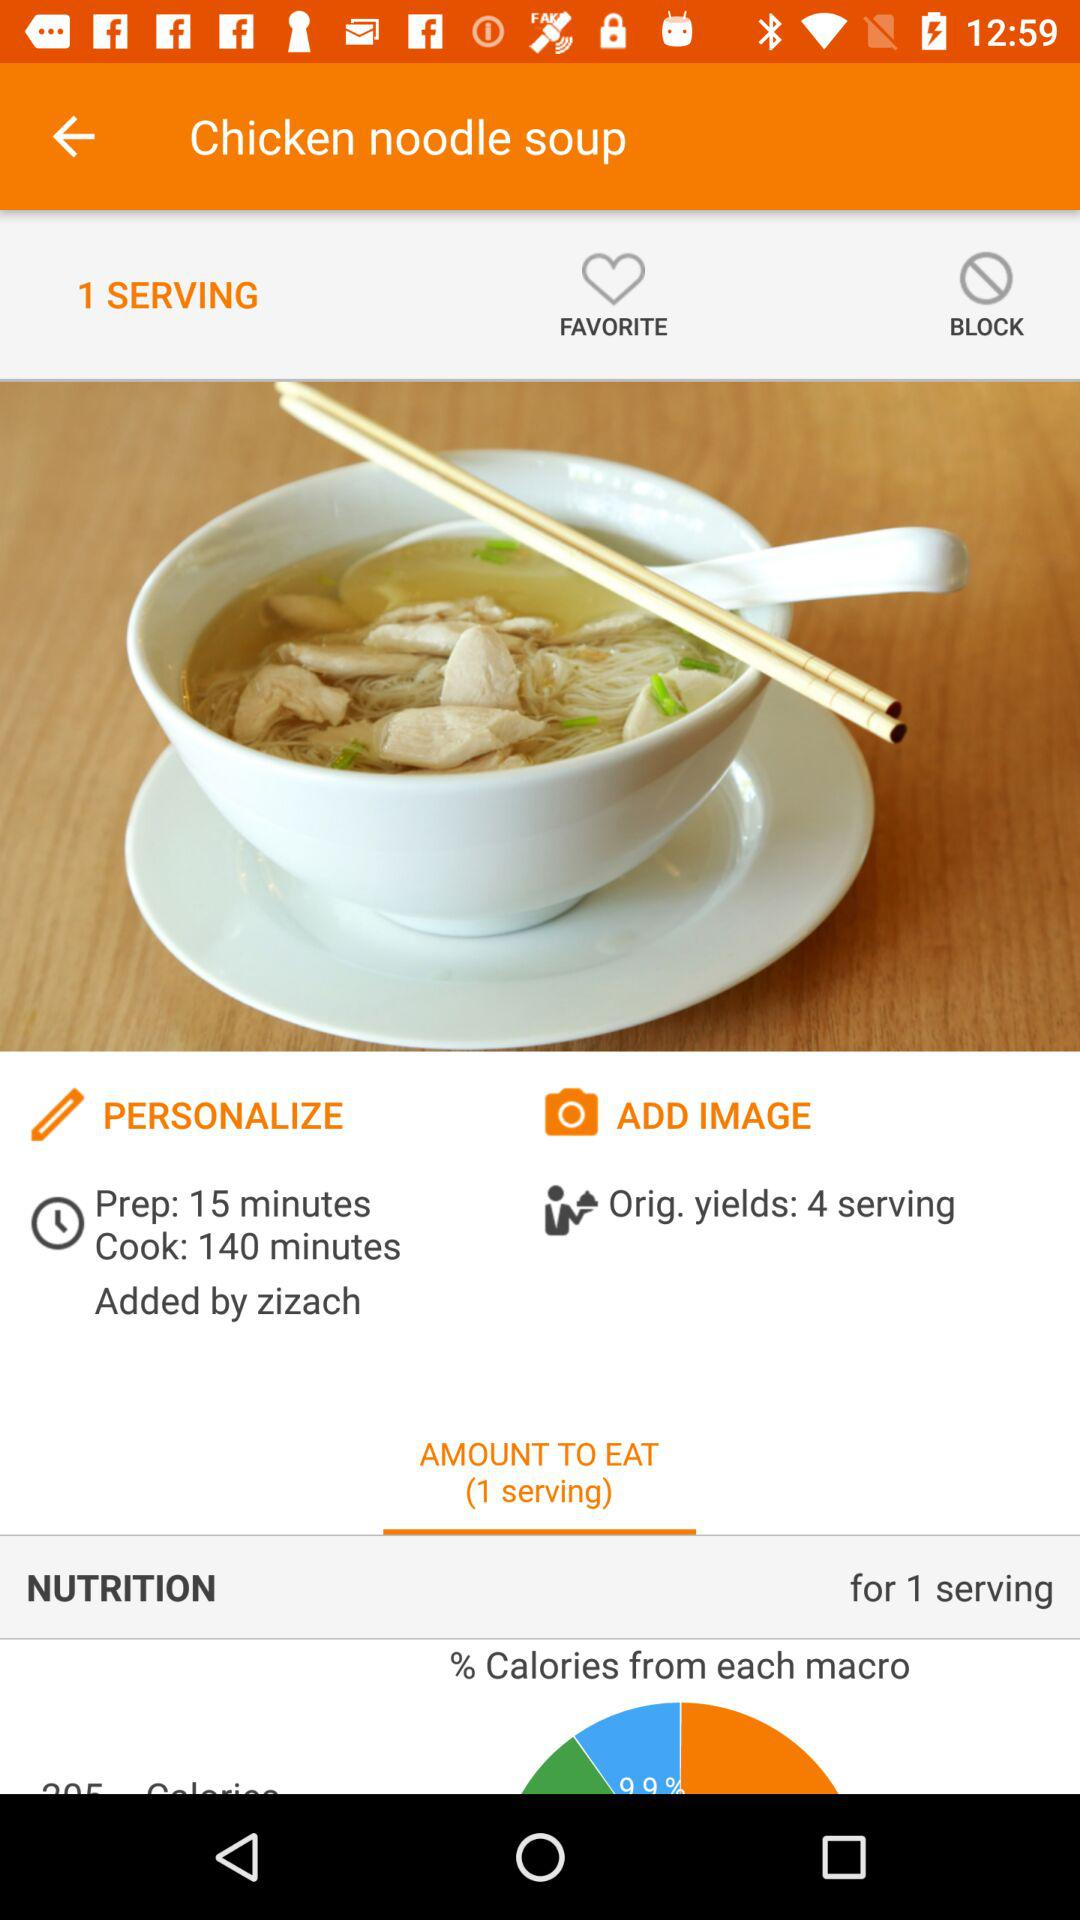How long does the dish take to cook? The dish takes 140 minutes to cook. 